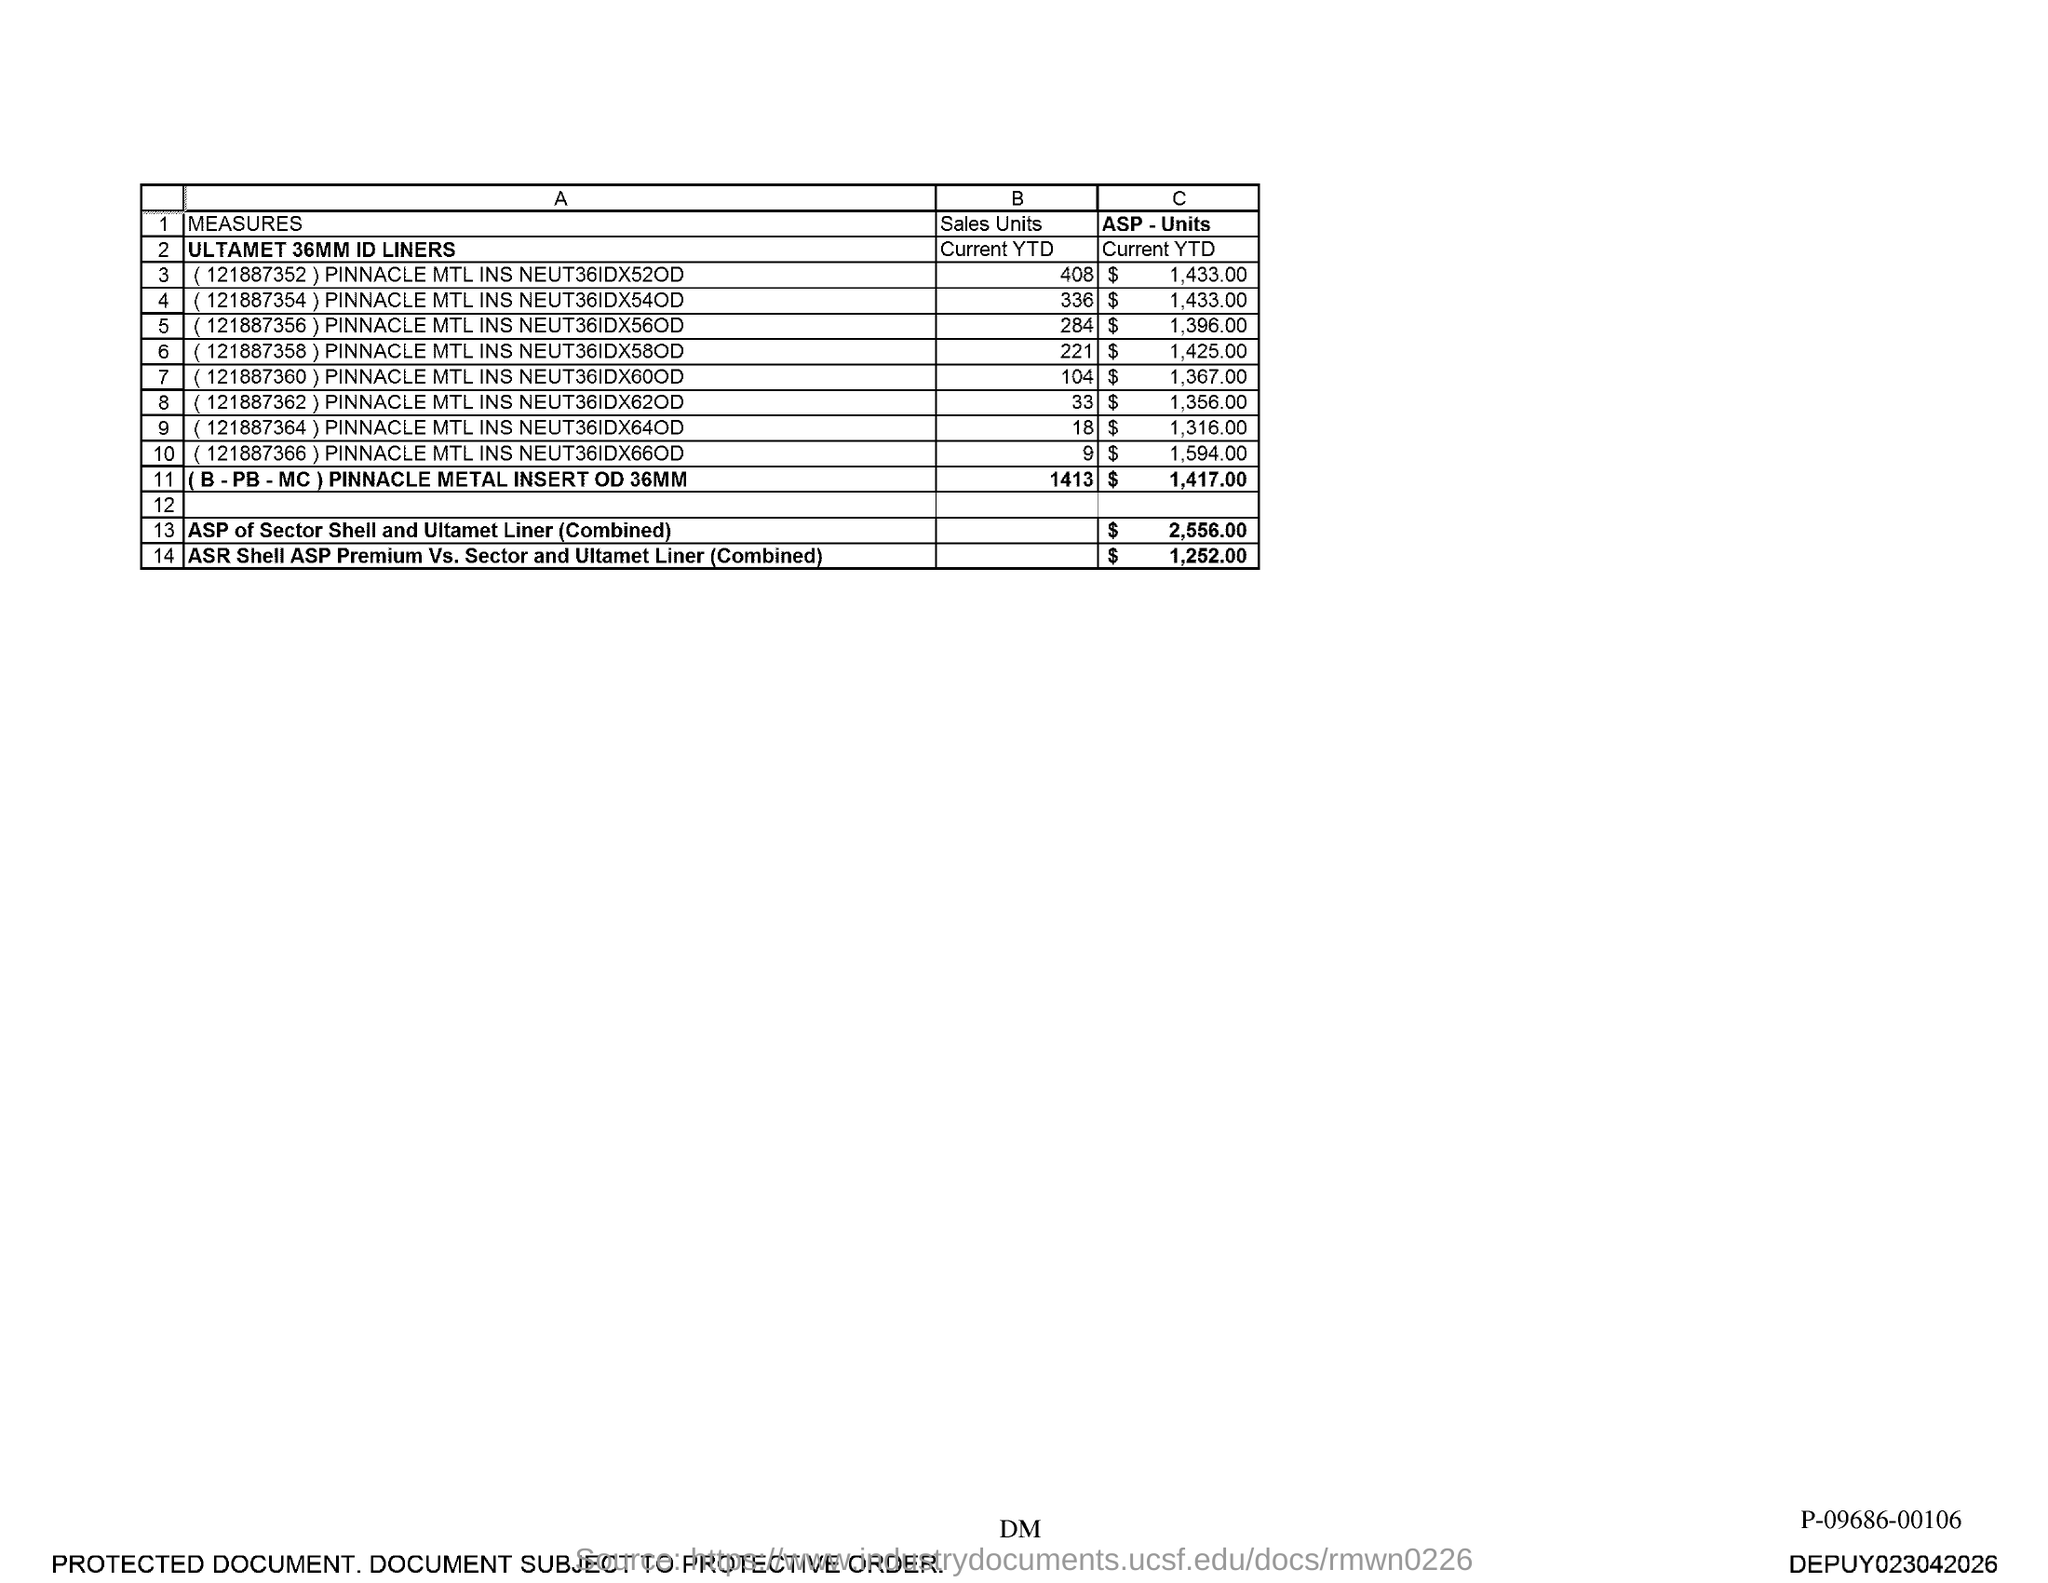What is the sales units for (121887352) pinnacle mtl ins neut36idx52od?
Your answer should be compact. 408. 